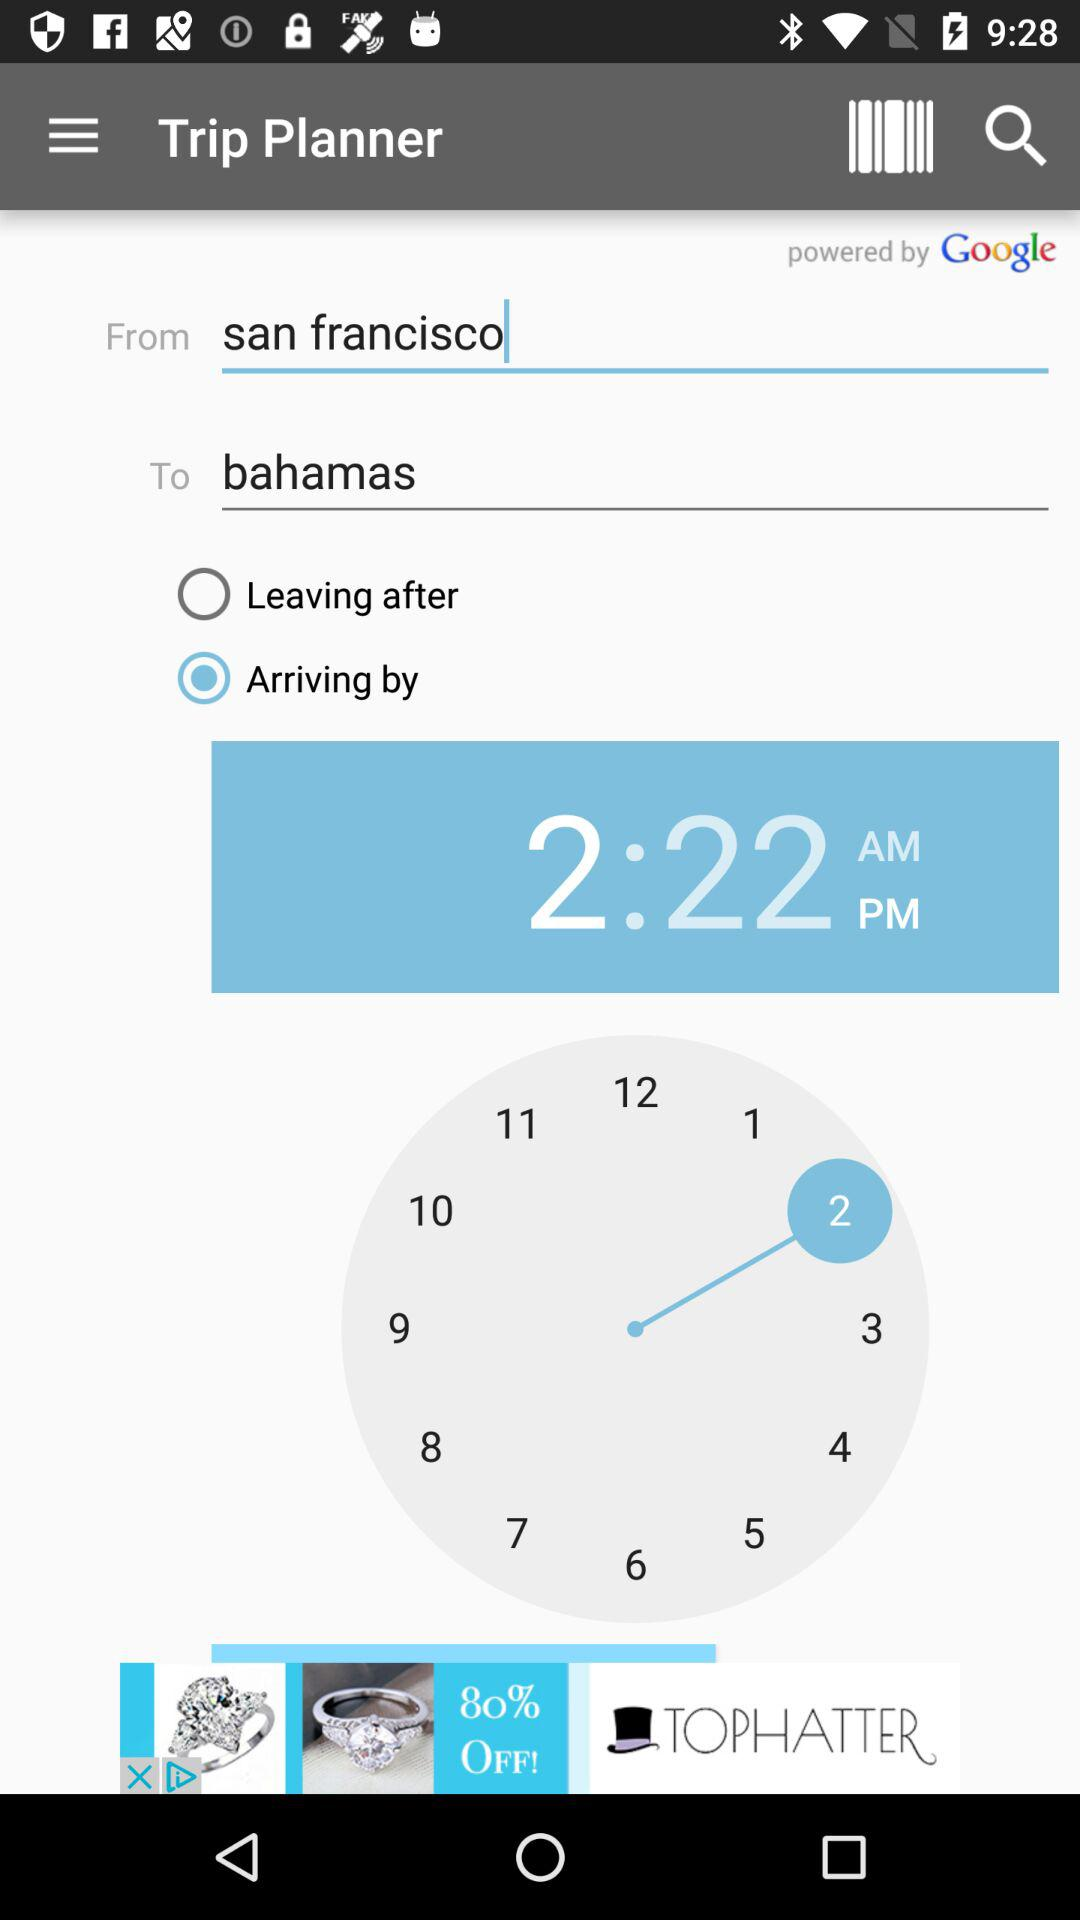What is the "From" location? The "From" location is San Francisco. 